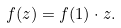Convert formula to latex. <formula><loc_0><loc_0><loc_500><loc_500>f ( z ) = f ( 1 ) \cdot z .</formula> 